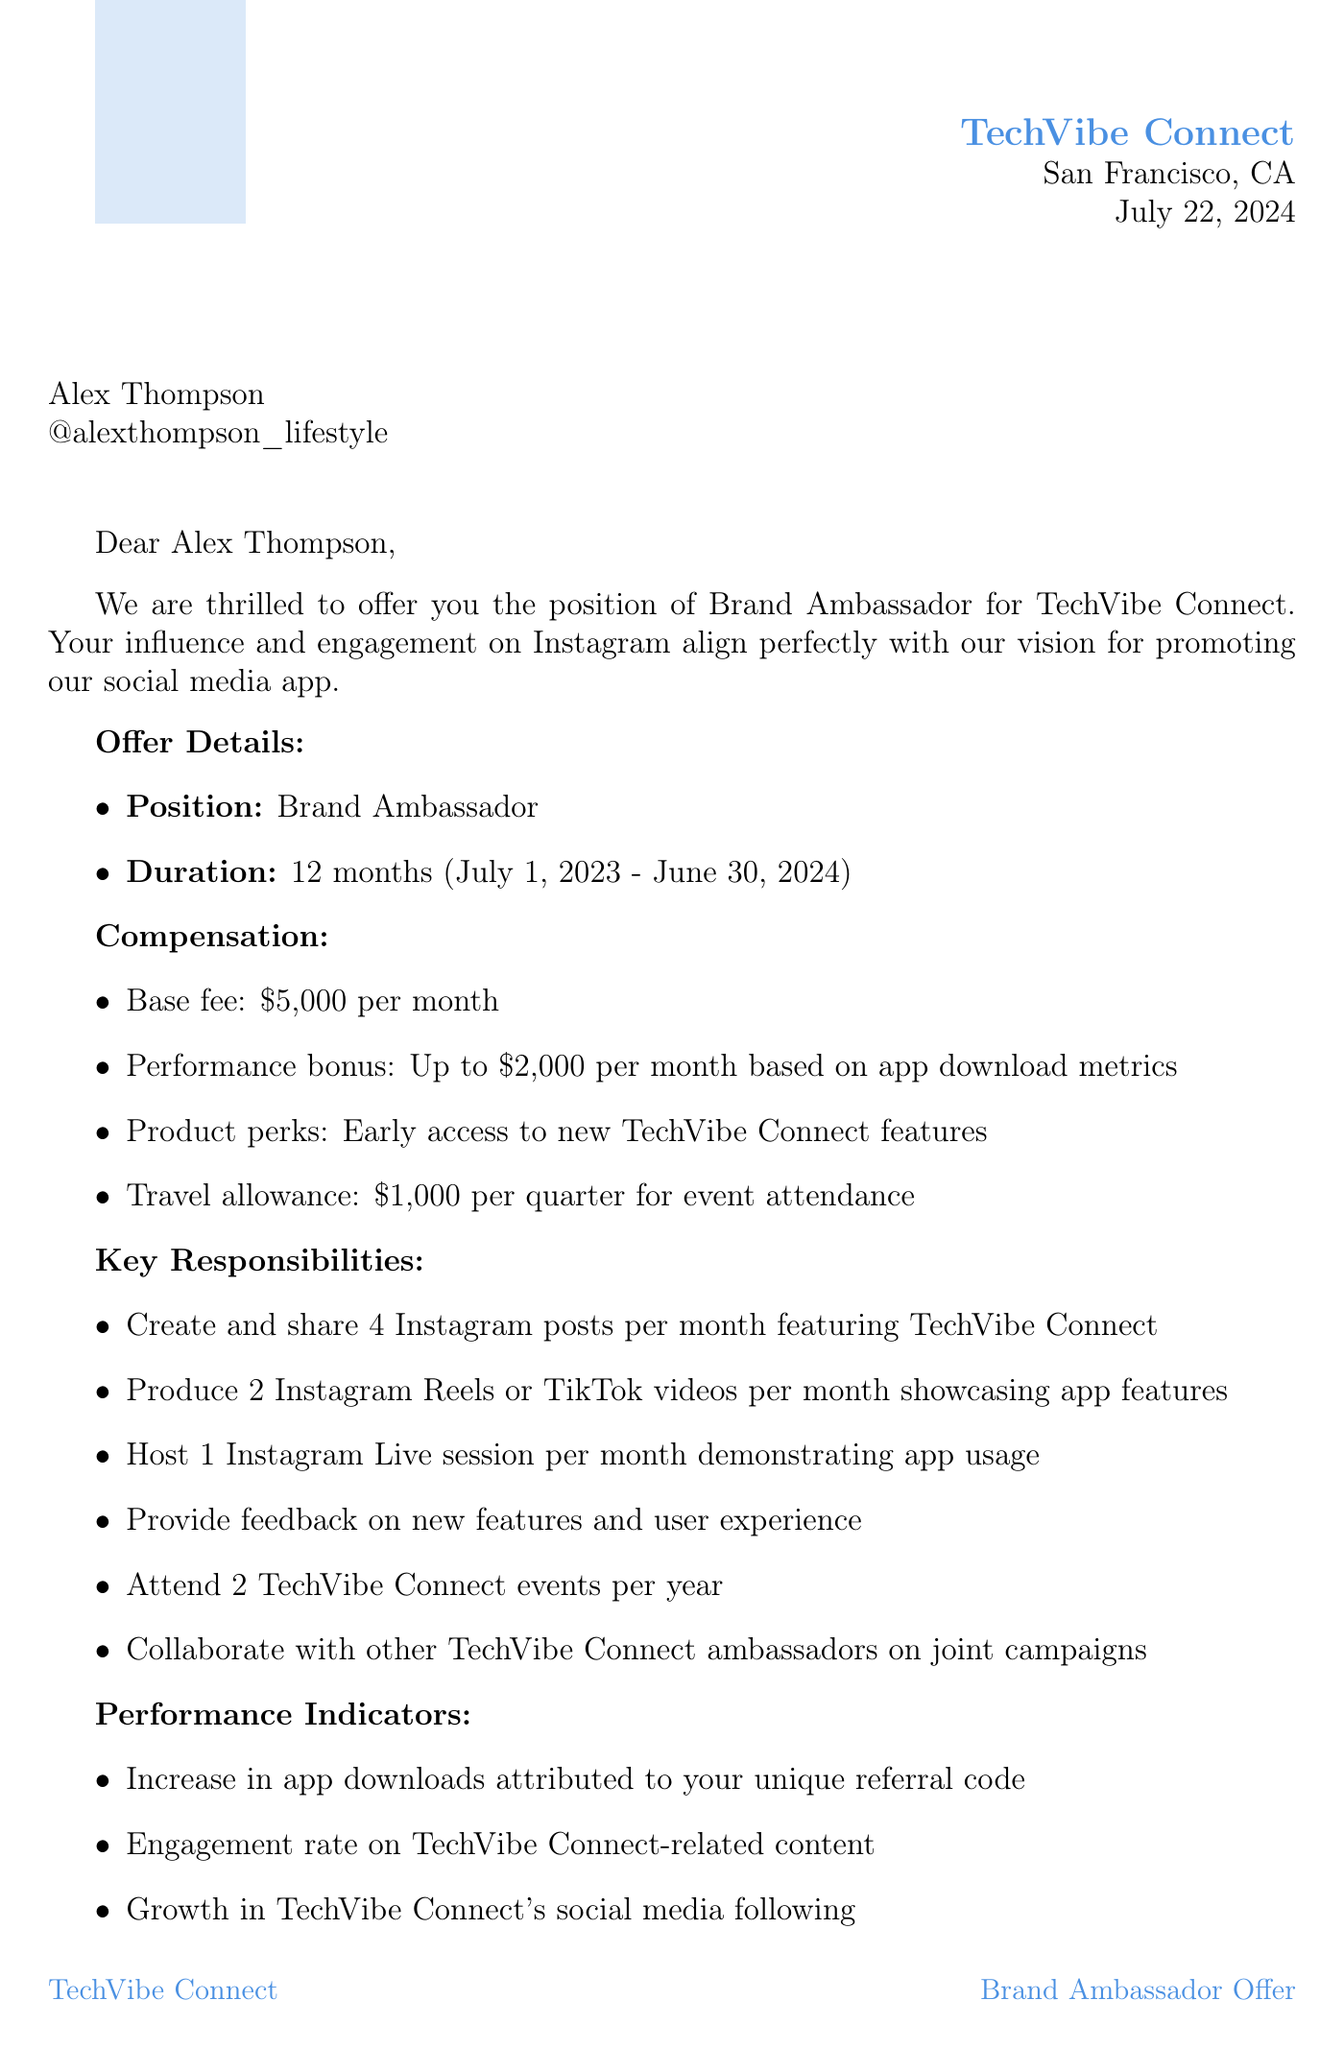What is the position offered? The document states that the position offered is specified in the offer details section.
Answer: Brand Ambassador Who is the influencer representative? The document lists the brand representative along with their position and contact information.
Answer: Sarah Chen What is the monthly base fee? The compensation section specifies the monthly base fee for the role.
Answer: $5,000 per month How long is the contract duration? The offer details section indicates the length of the contract.
Answer: 12 months What is the start date of the contract? The offer details section provides the beginning date for the ambassador role.
Answer: July 1, 2023 How many Instagram posts must be created monthly? The key responsibilities outline the content requirements for the influencer.
Answer: 4 What are the approved hashtags to use? The brand guidelines section lists the hashtags that are permitted for use.
Answer: #TechVibeConnect, #StayConnected, #SocialMediaRevolution What happens if minimum content requirements are not met? The termination conditions detail reasons that could lead to ending the contract.
Answer: Failure to meet minimum content requirements for two consecutive months What is the travel allowance per quarter? The compensation section states the financial support provided for travel costs.
Answer: $1,000 per quarter 